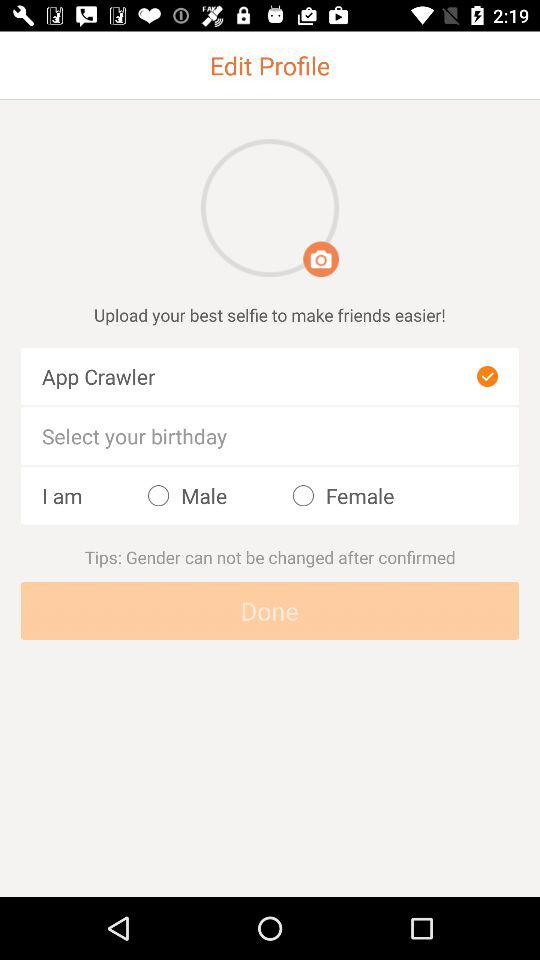How many text input elements are there?
Answer the question using a single word or phrase. 2 